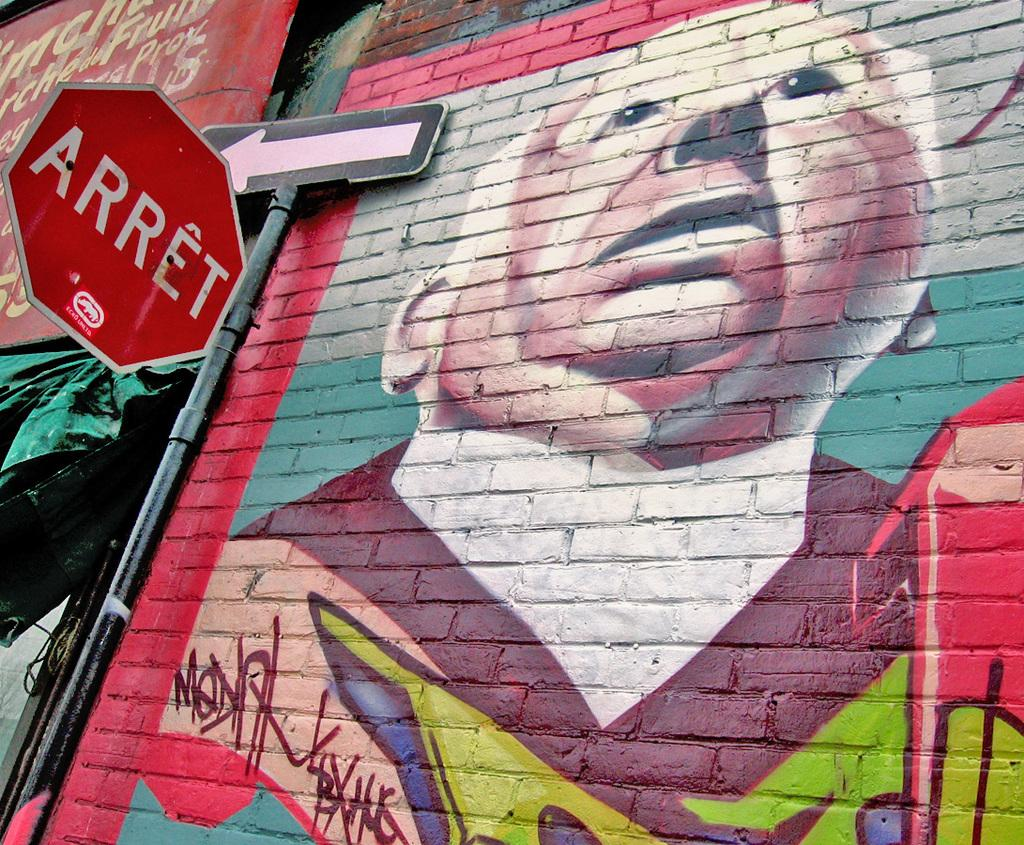<image>
Write a terse but informative summary of the picture. On a one-way street in a foreign land, STOP signs read "ARRET." 